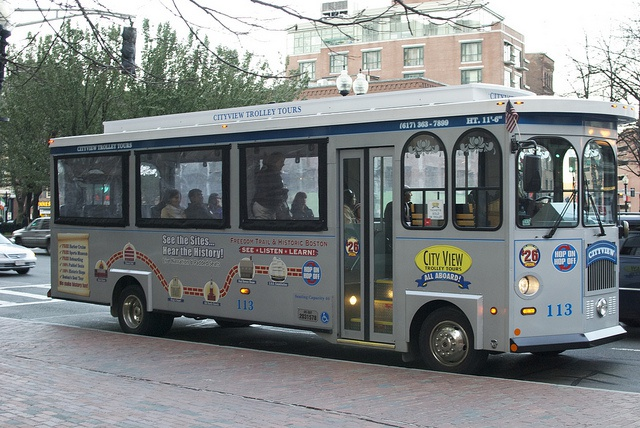Describe the objects in this image and their specific colors. I can see bus in ivory, gray, black, and darkgray tones, car in ivory, black, darkblue, and gray tones, people in ivory, black, and gray tones, car in ivory, white, darkgray, black, and gray tones, and car in ivory, gray, black, purple, and lightgray tones in this image. 